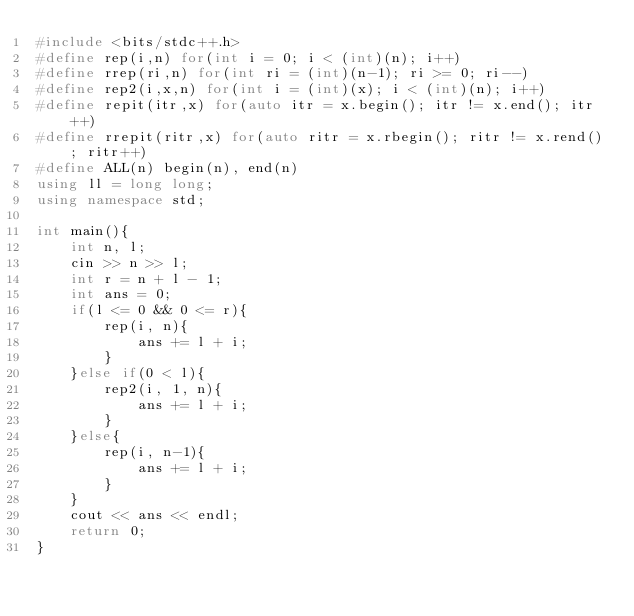Convert code to text. <code><loc_0><loc_0><loc_500><loc_500><_C++_>#include <bits/stdc++.h>
#define rep(i,n) for(int i = 0; i < (int)(n); i++)
#define rrep(ri,n) for(int ri = (int)(n-1); ri >= 0; ri--)
#define rep2(i,x,n) for(int i = (int)(x); i < (int)(n); i++)
#define repit(itr,x) for(auto itr = x.begin(); itr != x.end(); itr++)
#define rrepit(ritr,x) for(auto ritr = x.rbegin(); ritr != x.rend(); ritr++)
#define ALL(n) begin(n), end(n)
using ll = long long;
using namespace std;

int main(){
	int n, l;
	cin >> n >> l;
	int r = n + l - 1;
	int ans = 0;
	if(l <= 0 && 0 <= r){
		rep(i, n){
			ans += l + i;
		}
	}else if(0 < l){
		rep2(i, 1, n){
			ans += l + i;
		}
	}else{
		rep(i, n-1){
			ans += l + i;
		}
	}
	cout << ans << endl;
	return 0;
}</code> 